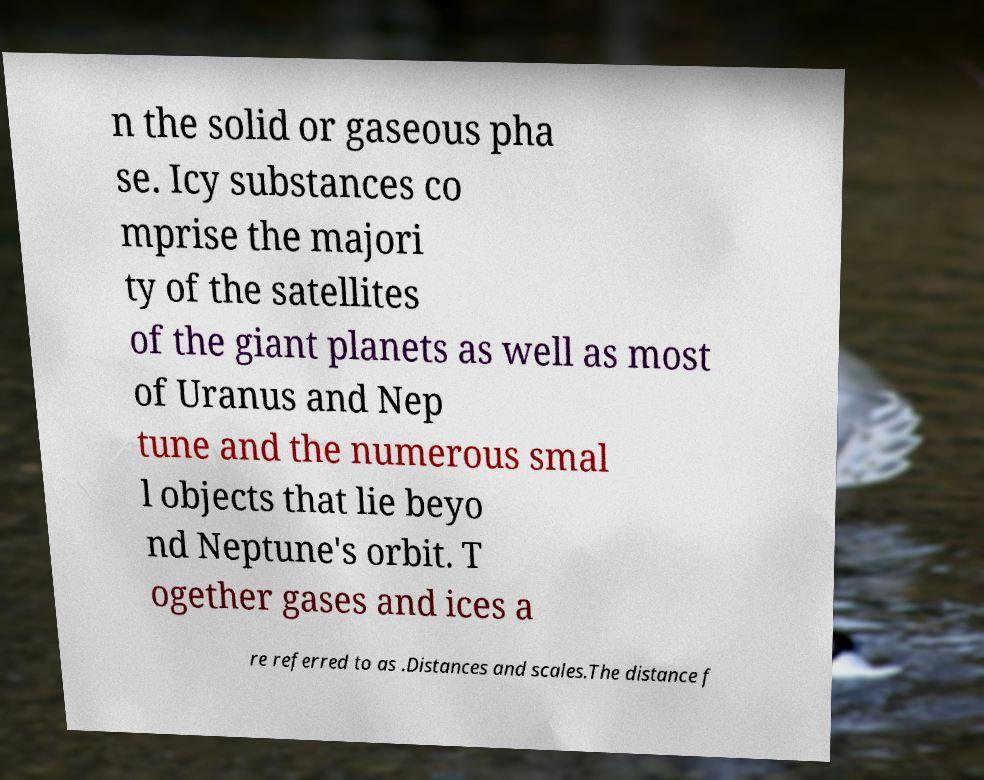For documentation purposes, I need the text within this image transcribed. Could you provide that? n the solid or gaseous pha se. Icy substances co mprise the majori ty of the satellites of the giant planets as well as most of Uranus and Nep tune and the numerous smal l objects that lie beyo nd Neptune's orbit. T ogether gases and ices a re referred to as .Distances and scales.The distance f 